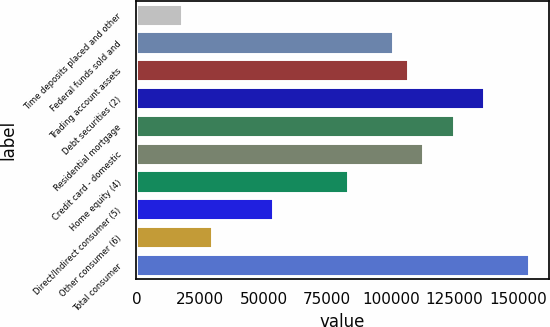Convert chart to OTSL. <chart><loc_0><loc_0><loc_500><loc_500><bar_chart><fcel>Time deposits placed and other<fcel>Federal funds sold and<fcel>Trading account assets<fcel>Debt securities (2)<fcel>Residential mortgage<fcel>Credit card - domestic<fcel>Home equity (4)<fcel>Direct/Indirect consumer (5)<fcel>Other consumer (6)<fcel>Total consumer<nl><fcel>17985.1<fcel>100931<fcel>106856<fcel>136479<fcel>124630<fcel>112780<fcel>83156.8<fcel>53533.3<fcel>29834.5<fcel>154253<nl></chart> 